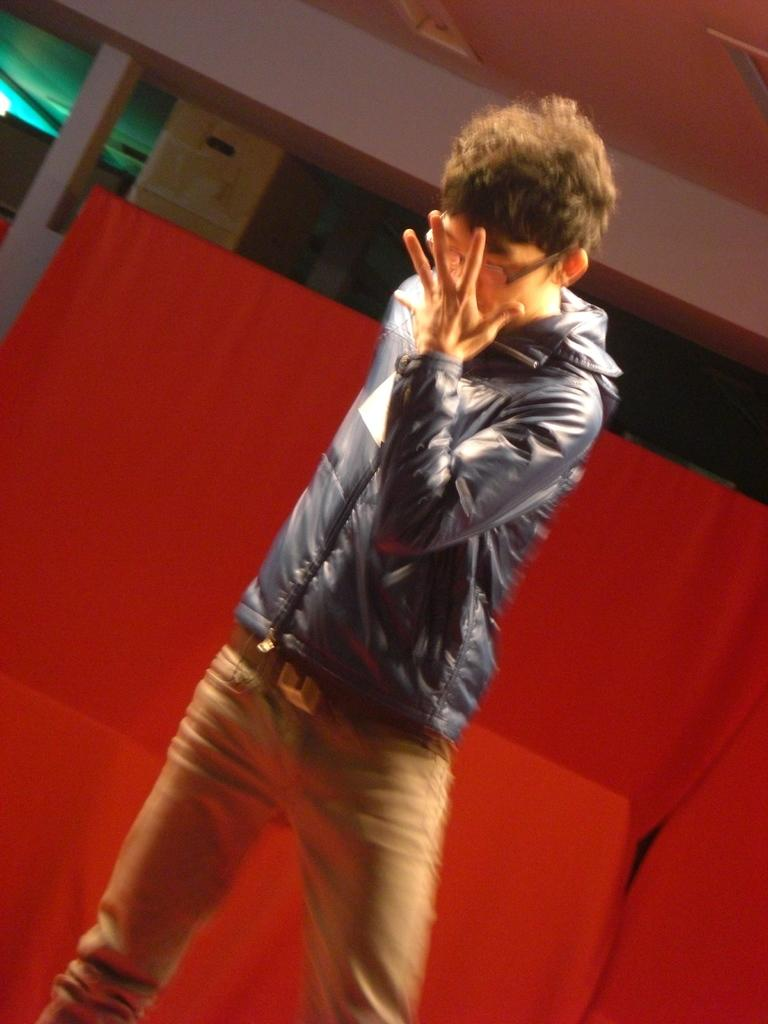What is the main subject of the image? There is a boy standing in the middle of the image. What can be seen in the background of the image? There is a wall in the background of the image. Are there any architectural features in the image? Yes, there is a pillar in the image. What color is the cloth visible in the image? There is a red-colored cloth in the image. What is visible at the top of the image? There is a roof visible at the top of the image. How many dolls are sitting on the boy's shoulders in the image? There are no dolls present in the image, so it is not possible to answer that question. 